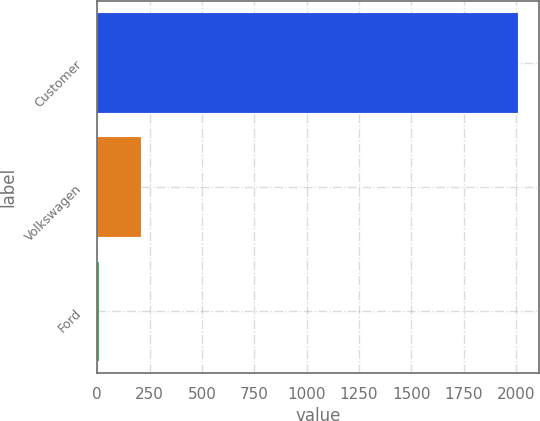Convert chart. <chart><loc_0><loc_0><loc_500><loc_500><bar_chart><fcel>Customer<fcel>Volkswagen<fcel>Ford<nl><fcel>2008<fcel>208.9<fcel>9<nl></chart> 